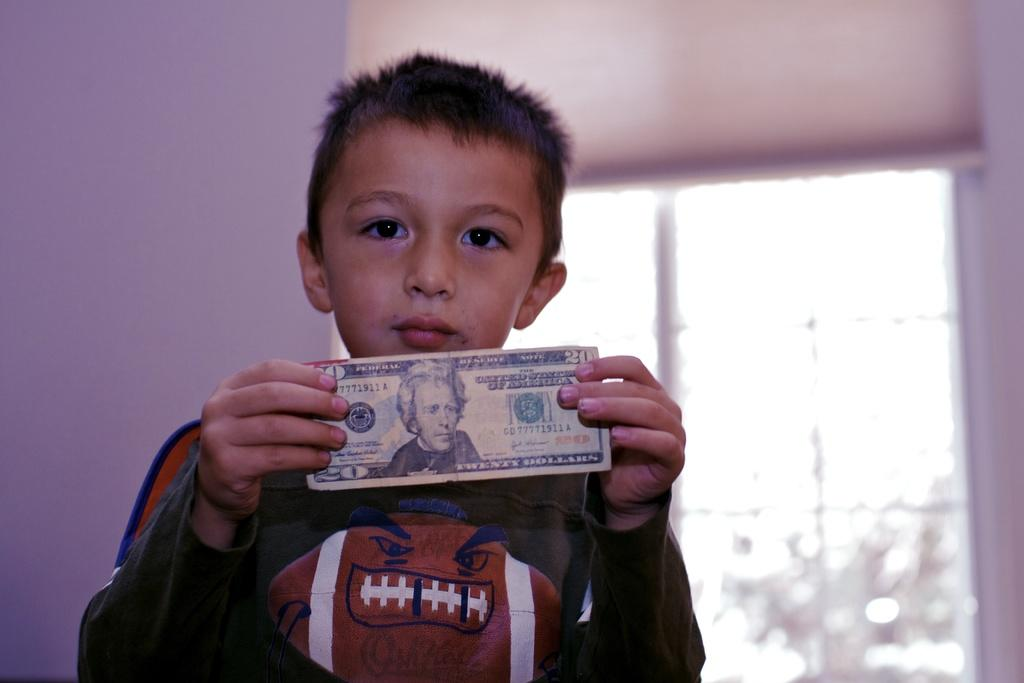Who is in the picture? There is a boy in the picture. What is the boy doing in the picture? The boy is standing in the picture. What is the boy holding in the picture? The boy is holding money in the picture. What can be seen in the background of the picture? There is a window and a wall in the background of the picture. What type of bread can be seen floating in the waves in the image? There is no bread or waves present in the image; it features a boy standing and holding money. 